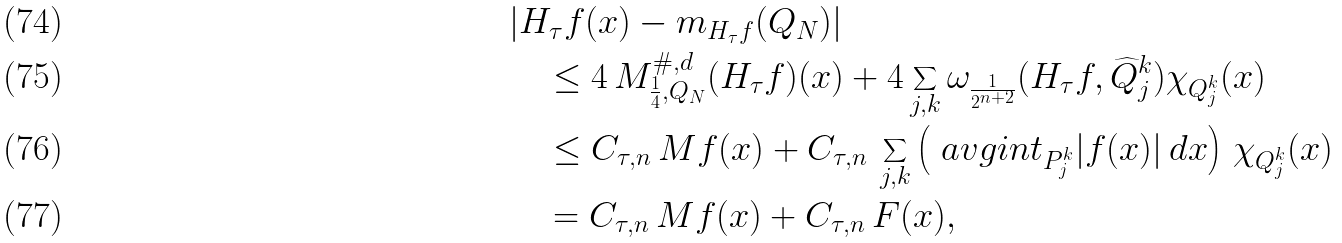<formula> <loc_0><loc_0><loc_500><loc_500>& | H _ { \tau } f ( x ) - m _ { H _ { \tau } f } ( Q _ { N } ) | \\ & \quad \leq 4 \, M ^ { \# , d } _ { \frac { 1 } { 4 } , Q _ { N } } ( H _ { \tau } f ) ( x ) + 4 \sum _ { j , k } \omega _ { \frac { 1 } { 2 ^ { n + 2 } } } ( H _ { \tau } f , \widehat { Q } _ { j } ^ { k } ) \chi _ { Q _ { j } ^ { k } } ( x ) \\ & \quad \leq C _ { \tau , n } \, M f ( x ) + C _ { \tau , n } \, \sum _ { j , k } \left ( \ a v g i n t _ { P _ { j } ^ { k } } | f ( x ) | \, d x \right ) \, \chi _ { Q _ { j } ^ { k } } ( x ) \\ & \quad = C _ { \tau , n } \, M f ( x ) + C _ { \tau , n } \, F ( x ) ,</formula> 